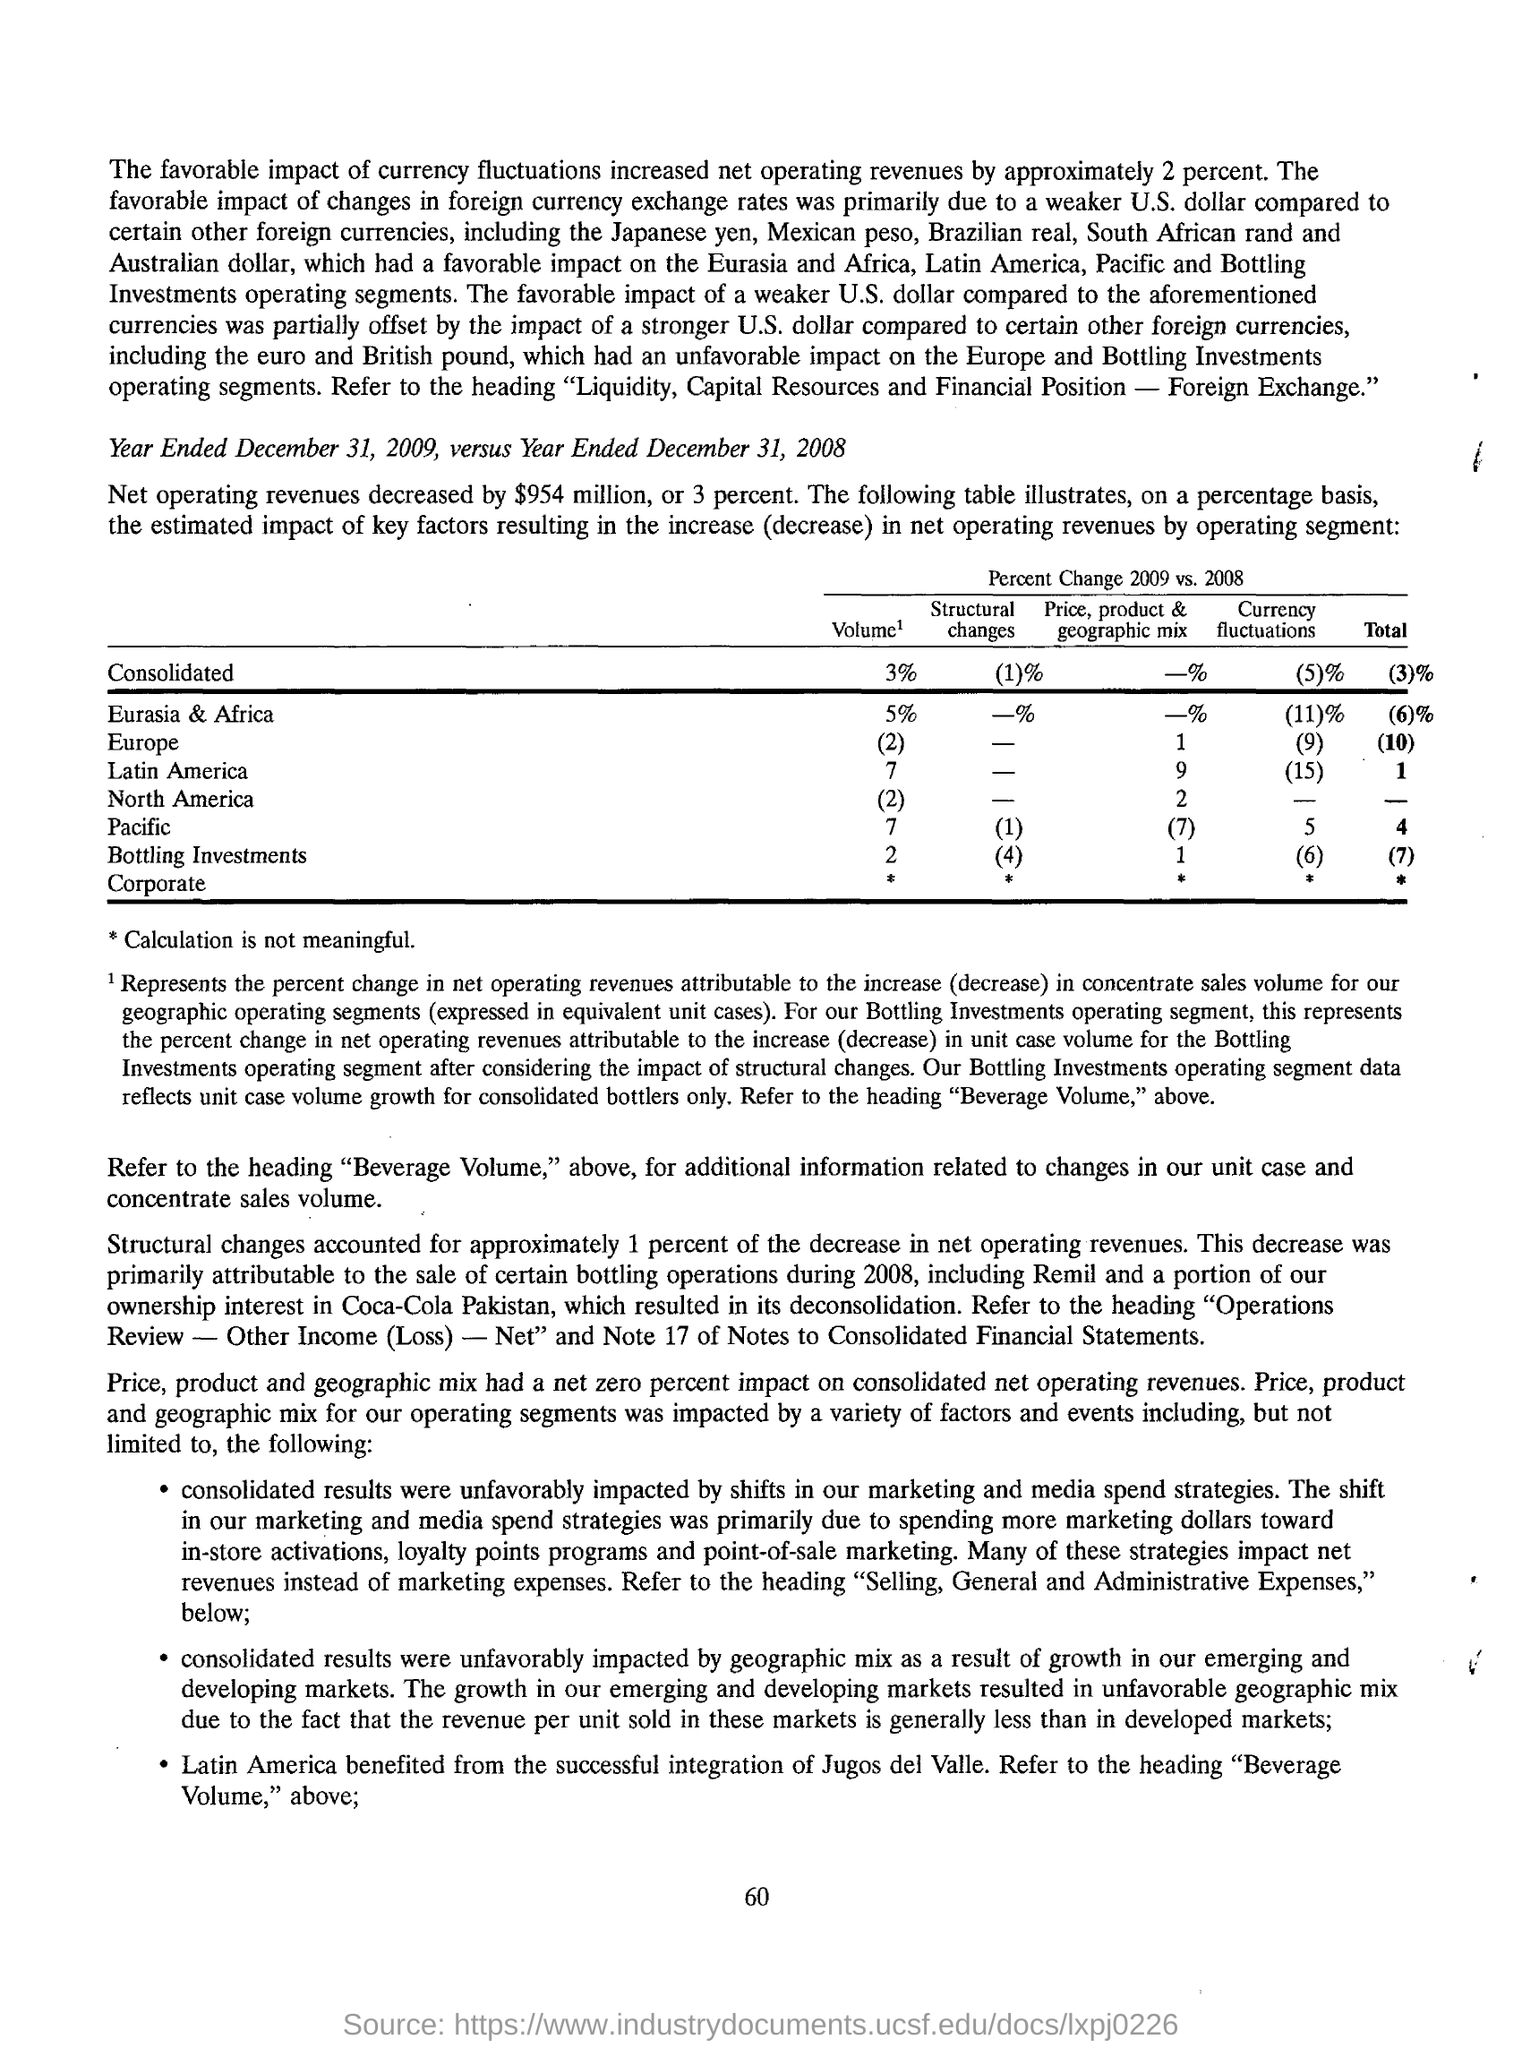Which country is benefited from the successful integration of jugos de valle?
Give a very brief answer. Latin America. What is the increase in net operating revenues as part of favorable impact of currency fluctuations?
Offer a terse response. By approximately 2 percent. Which financial year's net operating revenues are compared?
Make the answer very short. Year ended December 31, 2009, versus Year Ended December 31, 2008. 